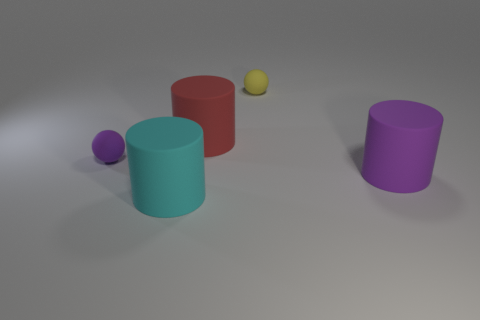Subtract all big cyan matte cylinders. How many cylinders are left? 2 Add 4 tiny matte things. How many objects exist? 9 Subtract all purple cylinders. How many cylinders are left? 2 Subtract 2 cylinders. How many cylinders are left? 1 Subtract all yellow cylinders. Subtract all red cubes. How many cylinders are left? 3 Subtract all cyan blocks. How many red cylinders are left? 1 Subtract all rubber spheres. Subtract all small yellow things. How many objects are left? 2 Add 2 yellow balls. How many yellow balls are left? 3 Add 5 large brown matte cylinders. How many large brown matte cylinders exist? 5 Subtract 0 green blocks. How many objects are left? 5 